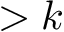Convert formula to latex. <formula><loc_0><loc_0><loc_500><loc_500>> k</formula> 